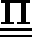<formula> <loc_0><loc_0><loc_500><loc_500>\underline { { \underline { \Pi } } }</formula> 